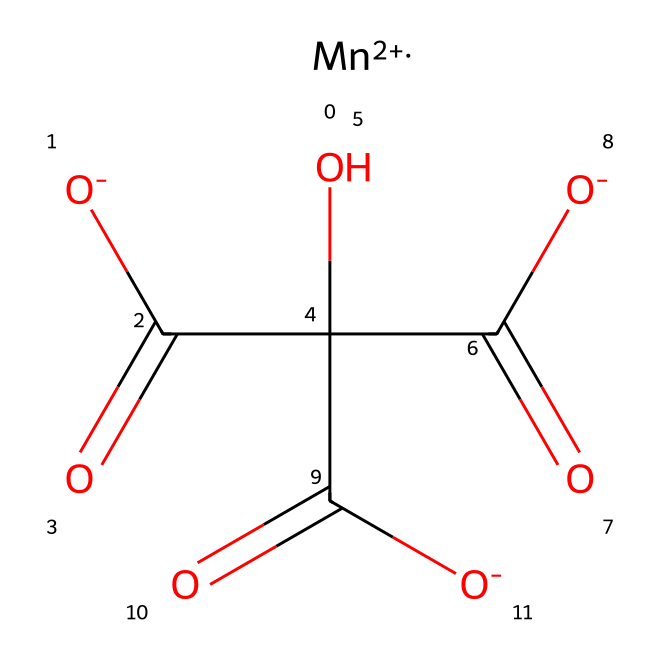What is the central metal atom in this structure? The chemical structure shows [Mn+2], indicating that manganese is the central metal atom in this coordination compound.
Answer: manganese How many carboxylate groups are present? There are three carboxylate groups in the structure, as indicated by the three instances of C(=O)[O-], representing -COO^- functionalities.
Answer: three What is the oxidation state of manganese in this compound? The oxidation state of manganese can be identified as +2, based on the notation [Mn+2] in the chemical structure.
Answer: +2 Which type of coordination compound is represented by this structure? The presence of manganese as a central metal coordinated by organic ligands, specifically carboxylate groups, indicates that this is a manganese-based coordination compound.
Answer: manganese-based coordination compound How many total oxygen atoms are present in the structure? Counting the oxygen atoms from the carboxylate groups and the hydroxyl group, we find there are a total of seven oxygen atoms (4 from carboxylate and 1 from hydroxyl group).
Answer: seven What type of ligands does manganese coordinate with in this compound? The manganese coordinates with carboxylate ligands, as suggested by the presence of the -COO^- groups in the structure, which are typical bidentate ligands.
Answer: carboxylate ligands 